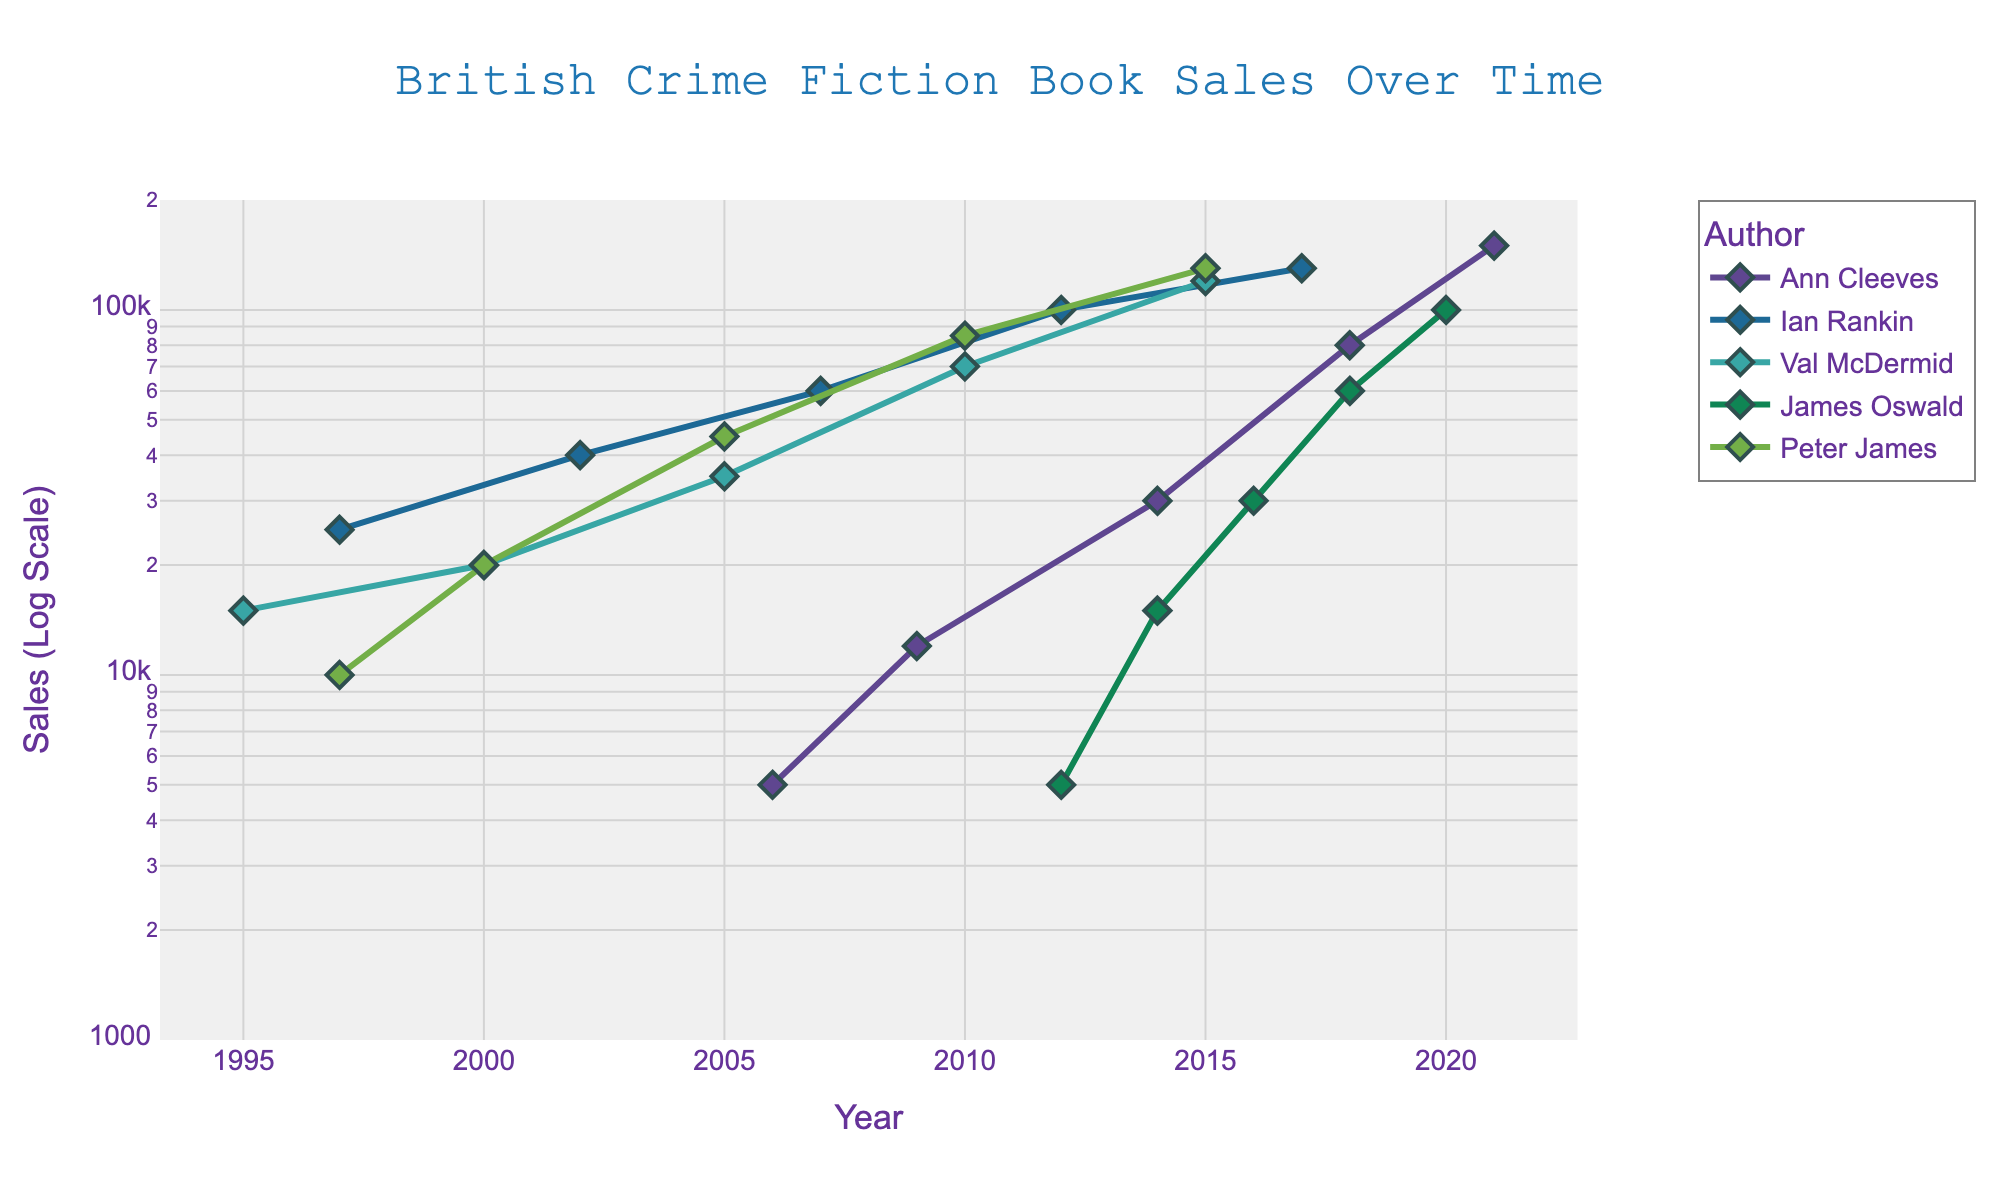what is the title of the plot? The title is located centrally at the top of the plot and reads "British Crime Fiction Book Sales Over Time".
Answer: British Crime Fiction Book Sales Over Time which authors are represented in the plot? The legend on the right side of the plot lists the authors included, which are Ann Cleeves, Ian Rankin, Val McDermid, James Oswald, and Peter James.
Answer: Ann Cleeves, Ian Rankin, Val McDermid, James Oswald, Peter James what are the sales values for Ann Cleeves in the year 2021? The Sales axis on the right indicates sales values in log scale. For Ann Cleeves in 2021, the point approximately aligns with the 150,000 mark on the y-axis.
Answer: 150,000 what is the pattern of sales growth over time for Ian Rankin between 1997 and 2017? Ian Rankin's data points show an increasing trend from 25,000 in 1997 to approximately 130,000 in 2017, marked by a steady rise in sales indicated by the upward movement of points.
Answer: Increasing Trend which author had a sales spike between 2012 and 2018? James Oswald had a significant increase in sales, starting around 5,000 in 2012 and reaching about 60,000 in 2018, as seen by a steep rise in the points connecting these years.
Answer: James Oswald how does the growth rate of Val McDermid's sales compare to Peter James' from 1995 to 2015? Comparing both authors' trajectories: Val McDermid starts at 15,000 in 1995 and goes up to about 120,000 by 2015, showing consistent but less steep growth, while Peter James’ sales rise from about 10,000 to 130,000 over the same period, indicating a slightly faster growth rate.
Answer: Peter James has a slightly faster growth rate what is the average sales in 2010 across all authors? For the year 2010, the sales for each author are Val McDermid at 70,000, Ian Rankin at 100,000, and Peter James at 85,000. The average sales value is calculated by summing these sales (70,000 + 100,000 + 85,000) and then dividing by the number of data points (3).
Answer: 85,000 how do sales trends differ for Ann Cleeves and Ian Rankin between 2006 and 2012? Ann Cleeves shows modest growth from 5,000 to around 30,000 from 2006 to 2012. Ian Rankin starts higher at 25,000 in 2006 with a steadier increase to roughly 100,000 by 2012. Ian Rankin has a higher starting point and steady increase, while Ann Cleeves shows steeper growth from a lower base.
Answer: Ian Rankin Steadier Increase, Ann Cleeves Steeper from Lower Base what is the general trend in sales for British crime fiction books over the years according to the plot? Observing the general trend, most authors show an increasing pattern in sales over the years, indicating rising popularity and sales for British crime fiction books from 1995 to 2021.
Answer: Increasing Trend 